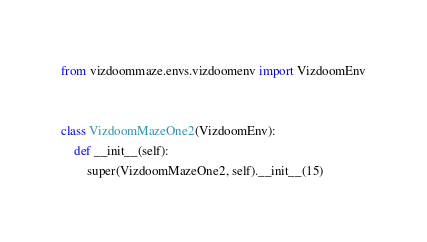<code> <loc_0><loc_0><loc_500><loc_500><_Python_>from vizdoommaze.envs.vizdoomenv import VizdoomEnv


class VizdoomMazeOne2(VizdoomEnv):
    def __init__(self):
        super(VizdoomMazeOne2, self).__init__(15)</code> 